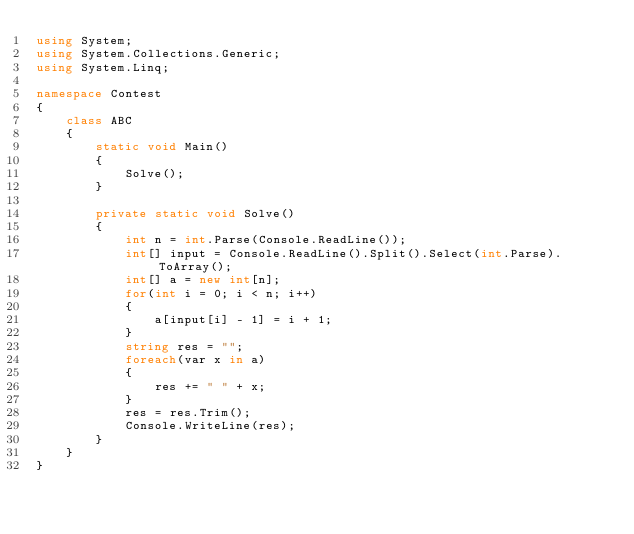<code> <loc_0><loc_0><loc_500><loc_500><_C#_>using System;
using System.Collections.Generic;
using System.Linq;

namespace Contest
{
    class ABC
    {
        static void Main()
        {
            Solve();
        }

        private static void Solve()
        {
            int n = int.Parse(Console.ReadLine());
            int[] input = Console.ReadLine().Split().Select(int.Parse).ToArray();
            int[] a = new int[n];
            for(int i = 0; i < n; i++)
            {
                a[input[i] - 1] = i + 1;
            }
            string res = "";
            foreach(var x in a)
            {
                res += " " + x;
            }
            res = res.Trim();
            Console.WriteLine(res);
        }
    }
}
</code> 